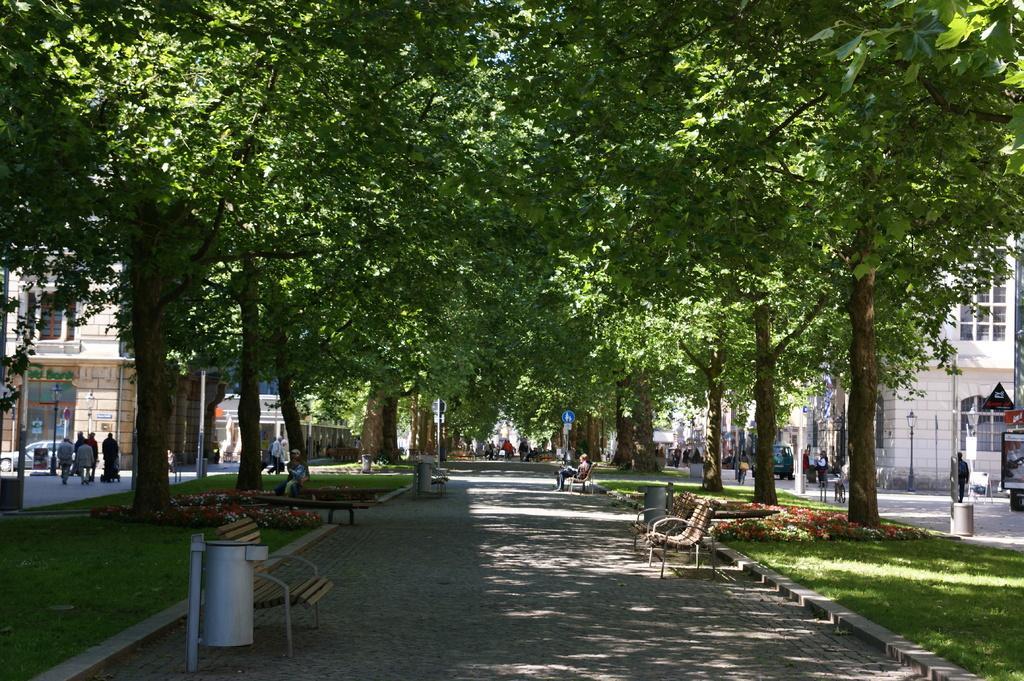Describe this image in one or two sentences. In this image I can see the road. On the road I can see the benches, dustbin and many people. On both sides of the road I can see many trees, people with different color dresses, boards and the buildings. 